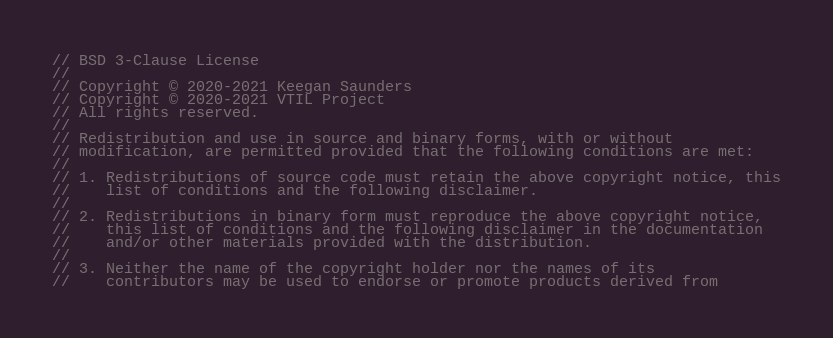Convert code to text. <code><loc_0><loc_0><loc_500><loc_500><_Rust_>// BSD 3-Clause License
//
// Copyright © 2020-2021 Keegan Saunders
// Copyright © 2020-2021 VTIL Project
// All rights reserved.
//
// Redistribution and use in source and binary forms, with or without
// modification, are permitted provided that the following conditions are met:
//
// 1. Redistributions of source code must retain the above copyright notice, this
//    list of conditions and the following disclaimer.
//
// 2. Redistributions in binary form must reproduce the above copyright notice,
//    this list of conditions and the following disclaimer in the documentation
//    and/or other materials provided with the distribution.
//
// 3. Neither the name of the copyright holder nor the names of its
//    contributors may be used to endorse or promote products derived from</code> 